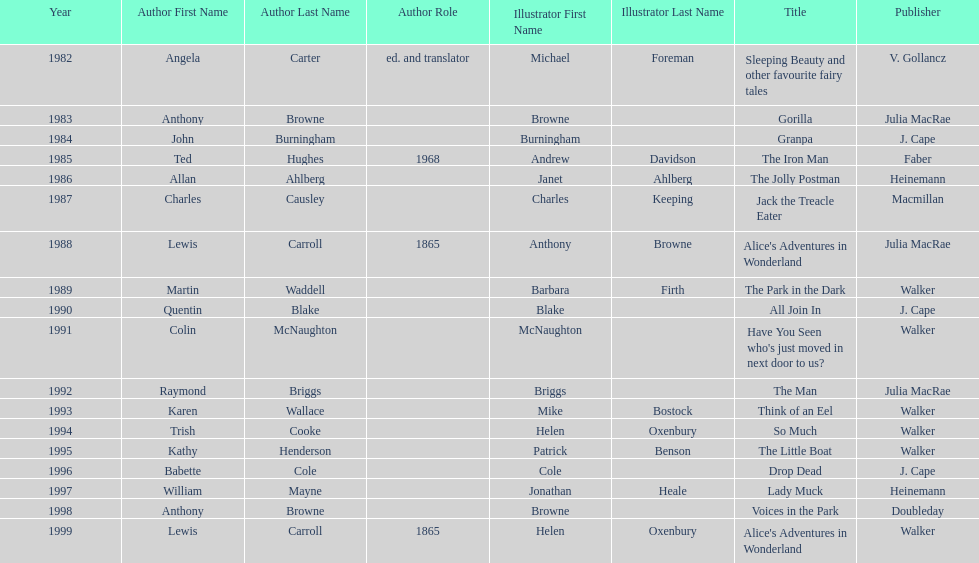Which other author, besides lewis carroll, has won the kurt maschler award twice? Anthony Browne. 